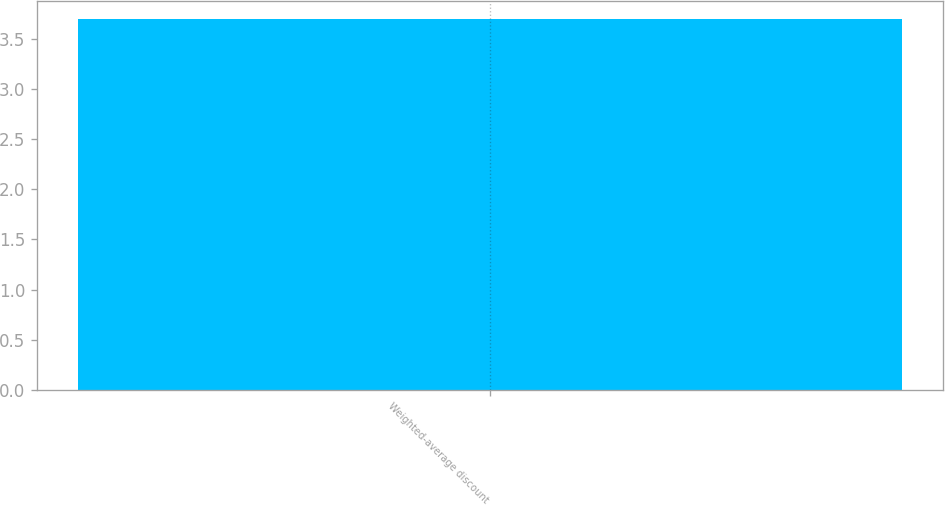<chart> <loc_0><loc_0><loc_500><loc_500><bar_chart><fcel>Weighted-average discount<nl><fcel>3.7<nl></chart> 